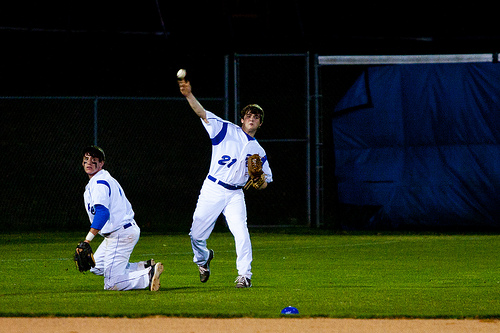Is there anything unique about the players' uniforms? The players' uniforms are predominantly white with blue detailing, which is a classic and professional color combination for a baseball team. The sharp contrast under the bright lights enhances the visibility of the players. 